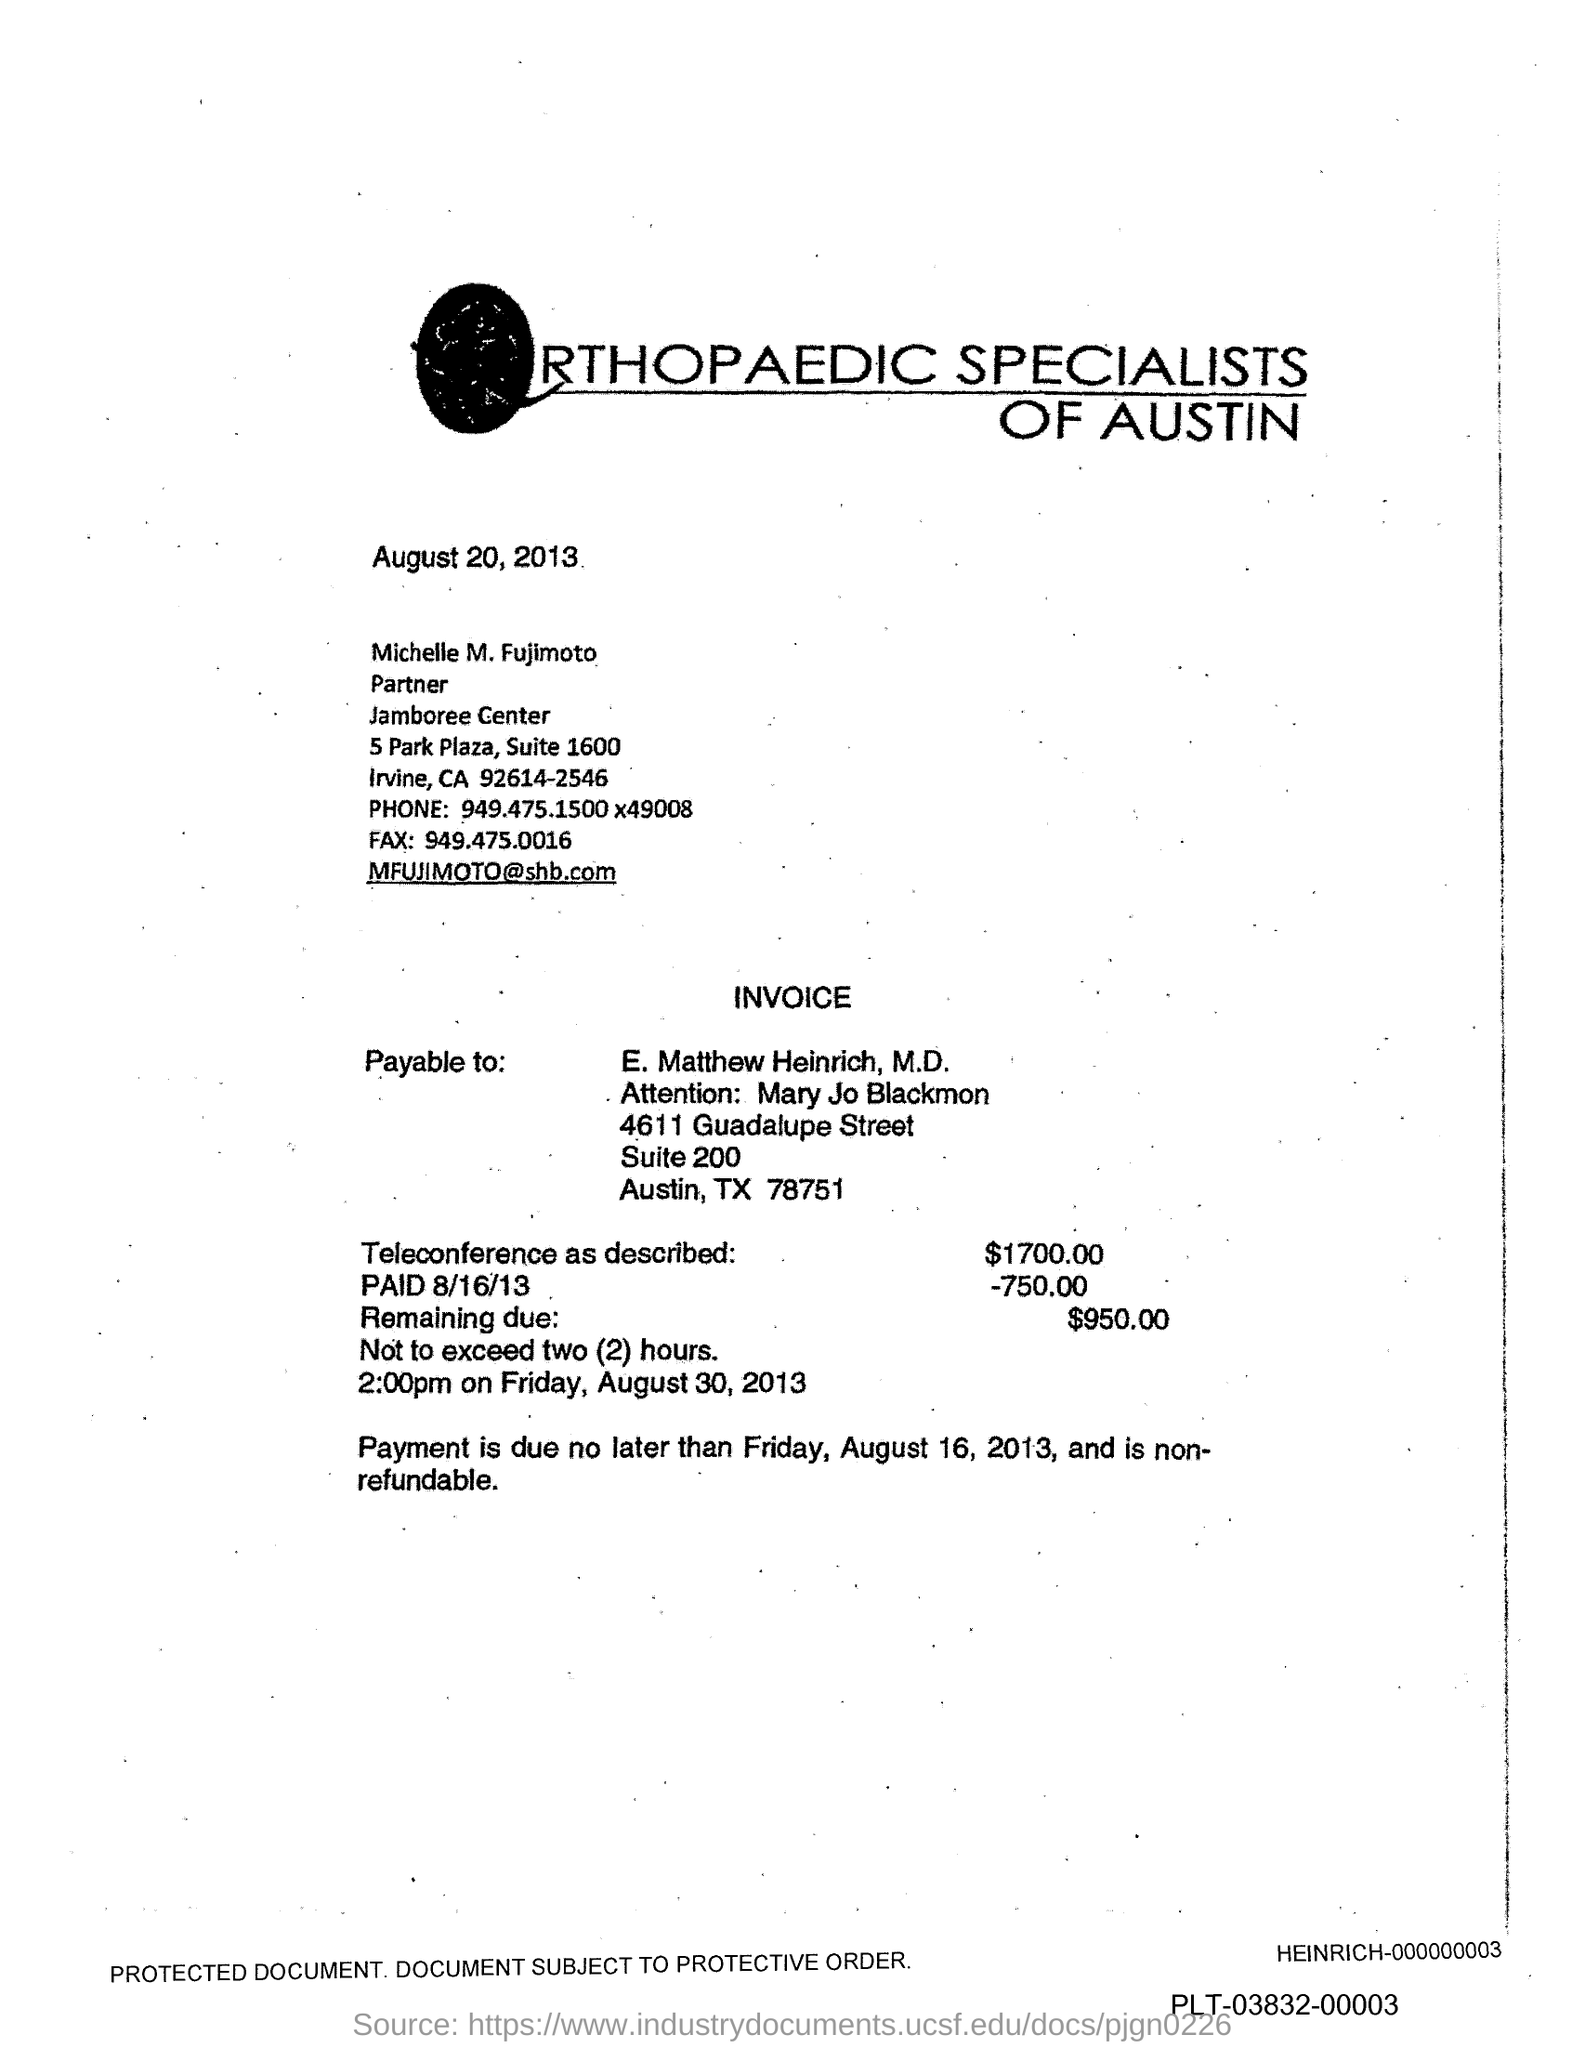What is the Fax number?
Your answer should be very brief. 949.475.0016. What is the phone number mentioned in the document?
Your answer should be compact. 949.475.1500 x49008. 